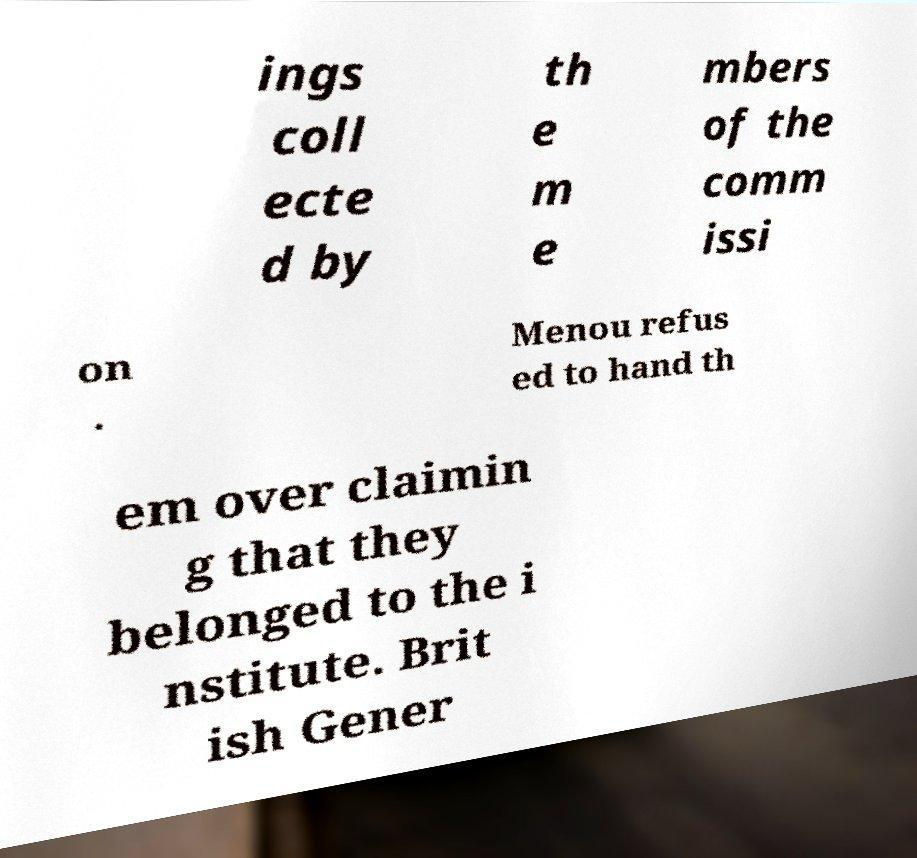I need the written content from this picture converted into text. Can you do that? ings coll ecte d by th e m e mbers of the comm issi on . Menou refus ed to hand th em over claimin g that they belonged to the i nstitute. Brit ish Gener 